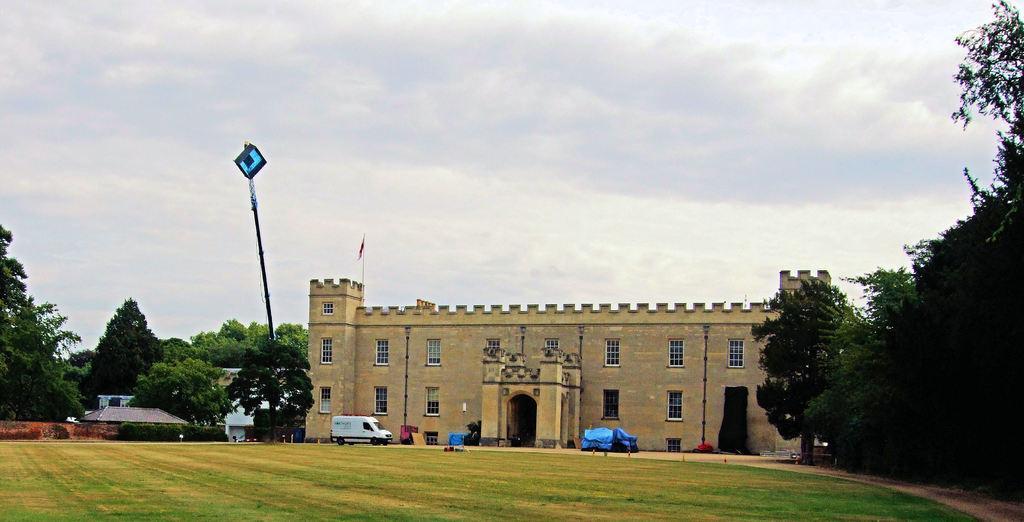Describe this image in one or two sentences. A vehicle is present. There is a building which has a flag on the top and there are trees on the either sides. 